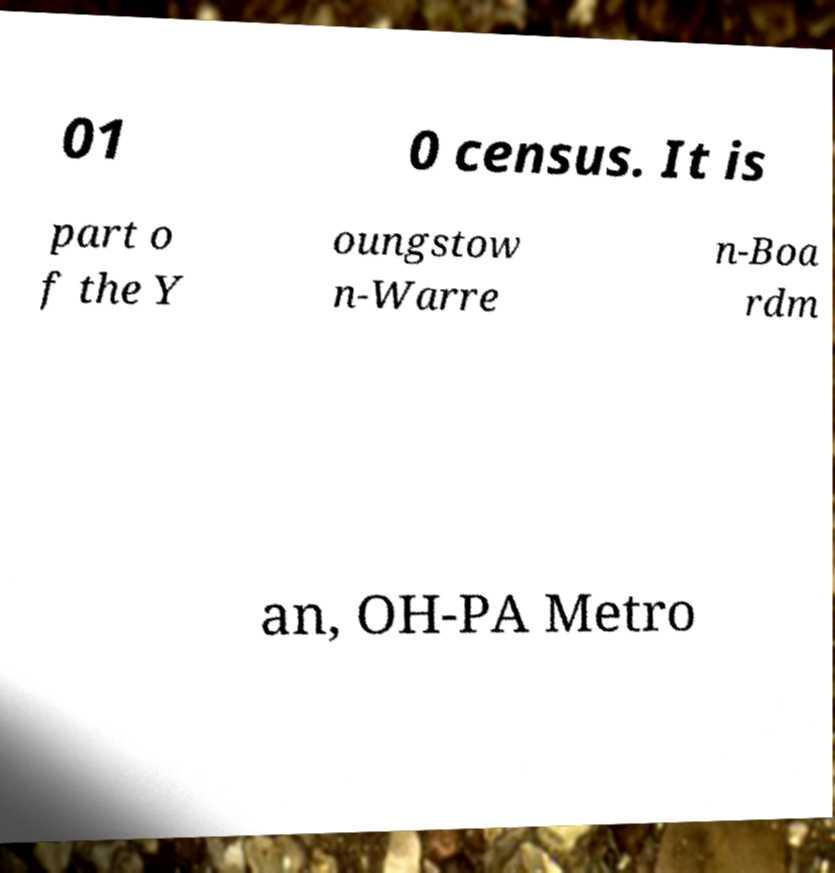What messages or text are displayed in this image? I need them in a readable, typed format. 01 0 census. It is part o f the Y oungstow n-Warre n-Boa rdm an, OH-PA Metro 